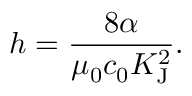Convert formula to latex. <formula><loc_0><loc_0><loc_500><loc_500>h = { \frac { 8 \alpha } { \mu _ { 0 } c _ { 0 } K _ { J } ^ { 2 } } } .</formula> 